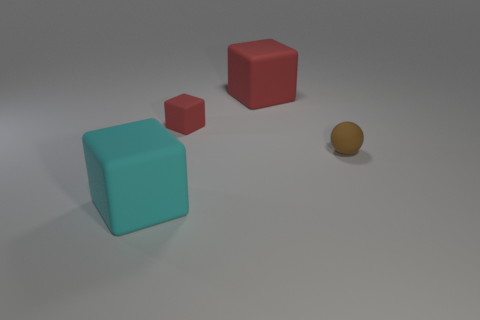What number of tiny red things have the same shape as the big red thing?
Your answer should be compact. 1. What material is the object that is the same size as the brown rubber sphere?
Give a very brief answer. Rubber. What size is the ball on the right side of the thing on the left side of the small matte thing that is behind the tiny ball?
Give a very brief answer. Small. There is a large block that is behind the big cyan rubber thing; is its color the same as the tiny rubber thing on the left side of the big red block?
Ensure brevity in your answer.  Yes. How many red things are either rubber cubes or small blocks?
Offer a terse response. 2. How many other rubber things are the same size as the cyan matte object?
Your answer should be compact. 1. Is the material of the large thing behind the big cyan thing the same as the tiny brown sphere?
Provide a short and direct response. Yes. There is a big rubber cube that is behind the small ball; is there a large cyan block that is in front of it?
Ensure brevity in your answer.  Yes. What is the material of the other large thing that is the same shape as the big cyan matte thing?
Ensure brevity in your answer.  Rubber. Is the number of big cyan rubber things in front of the brown rubber thing greater than the number of big cyan rubber objects that are on the right side of the cyan block?
Your answer should be very brief. Yes. 